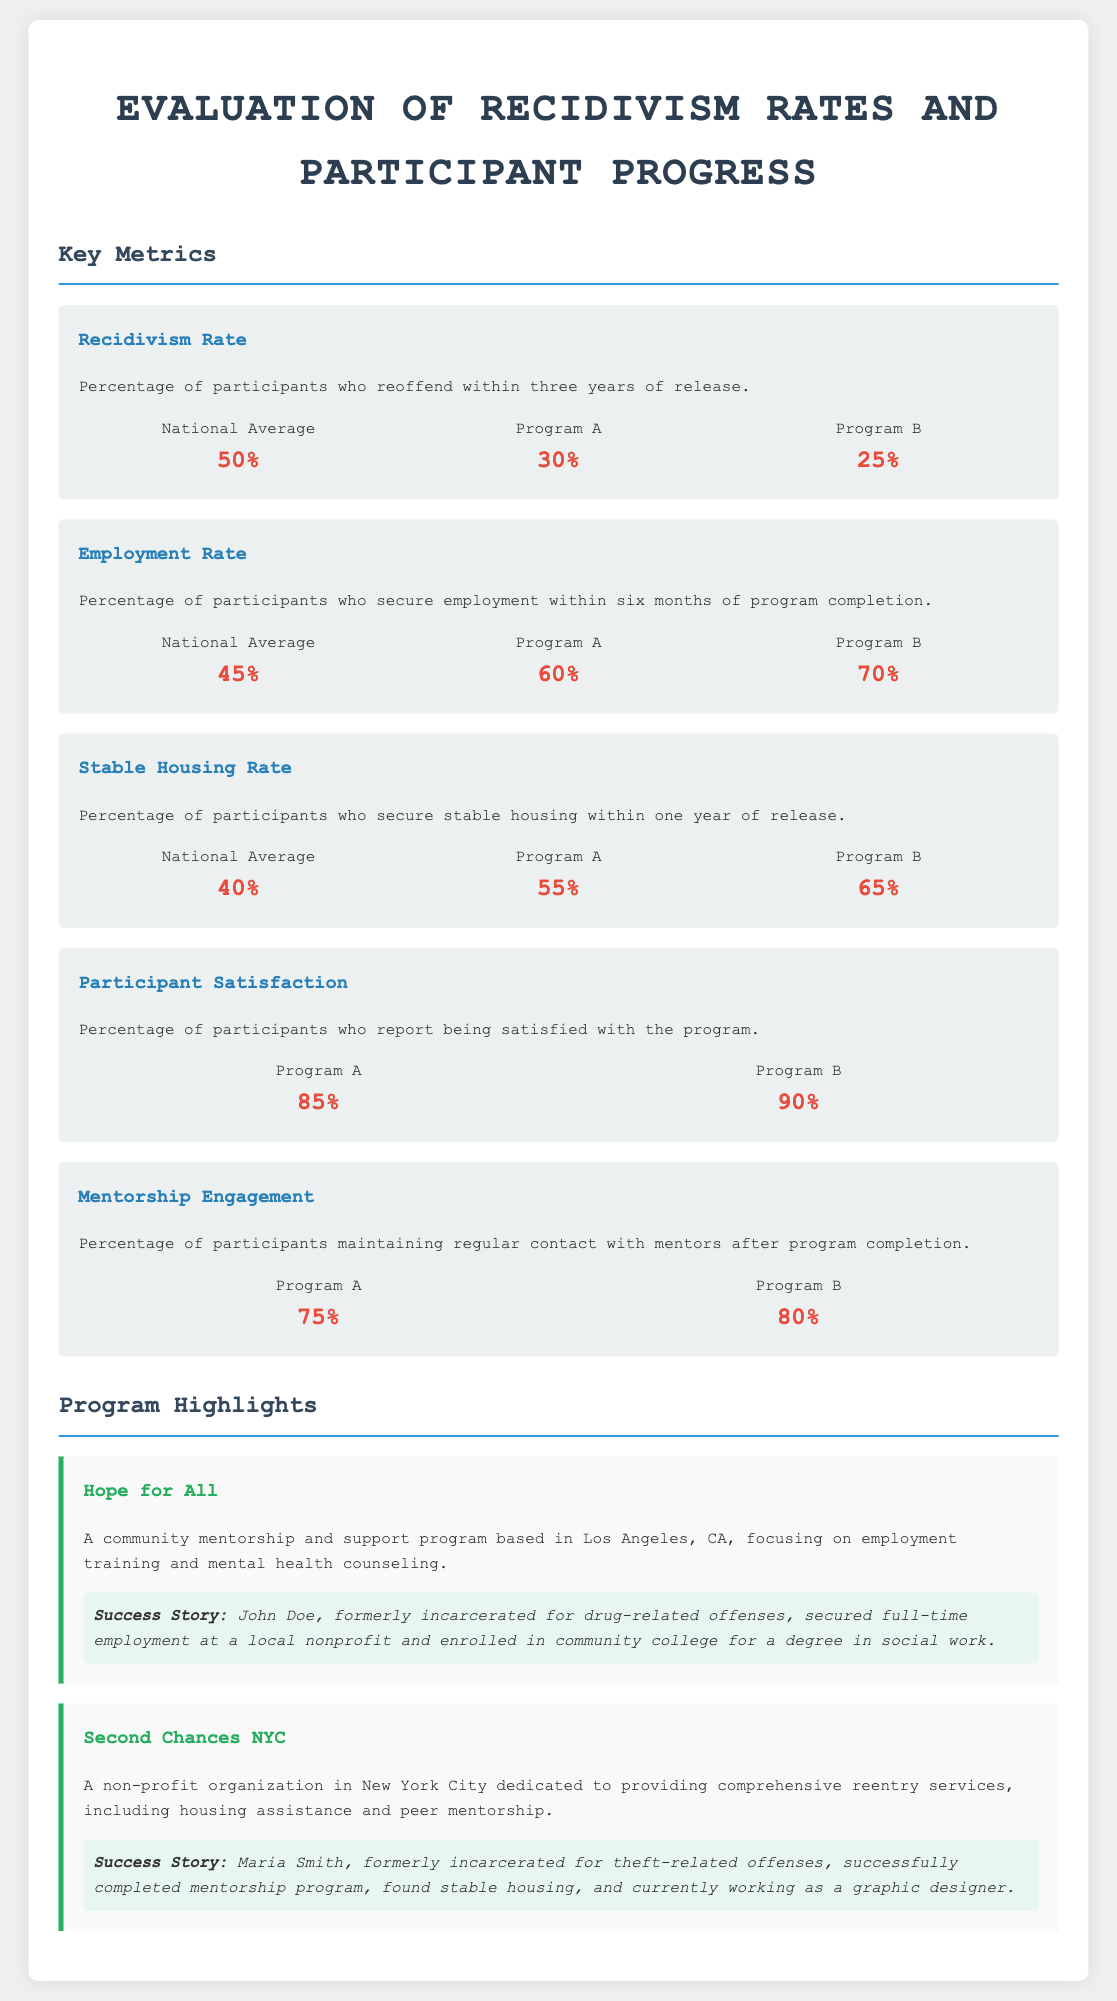What is the recidivism rate for Program A? The recidivism rate for Program A is presented under the Key Metrics section, specifically for "Program A," which is listed as 30%.
Answer: 30% What percentage of participants in Program B secure employment within six months of program completion? The employment rate for Program B is provided in the Key Metrics section, showing that 70% of participants secure employment.
Answer: 70% How many success stories are highlighted in the document? There are two success stories mentioned, one for each program, "Hope for All" and "Second Chances NYC."
Answer: 2 What is the stable housing rate for the national average? The stable housing rate for the national average is outlined in the Key Metrics section, which states it as 40%.
Answer: 40% Which program has the highest participant satisfaction percentage? The participant satisfaction rates are compared in the Key Metrics section, where Program B has the highest percentage at 90%.
Answer: 90% What does Program A focus on? Program A is described under Program Highlights as a community mentorship and support program focusing on employment training and mental health counseling.
Answer: Employment training and mental health counseling What is the percentage of participants maintaining regular contact with mentors in Program B? The mentorship engagement for Program B is documented in the Key Metrics section, which indicates that 80% of participants maintain contact with mentors.
Answer: 80% Which city is "Hope for All" based in? The location of "Hope for All" is specified in the document as being based in Los Angeles, CA.
Answer: Los Angeles, CA What is the national average employment rate within six months of program completion? The national average employment rate is given in the Key Metrics section, listed as 45%.
Answer: 45% 